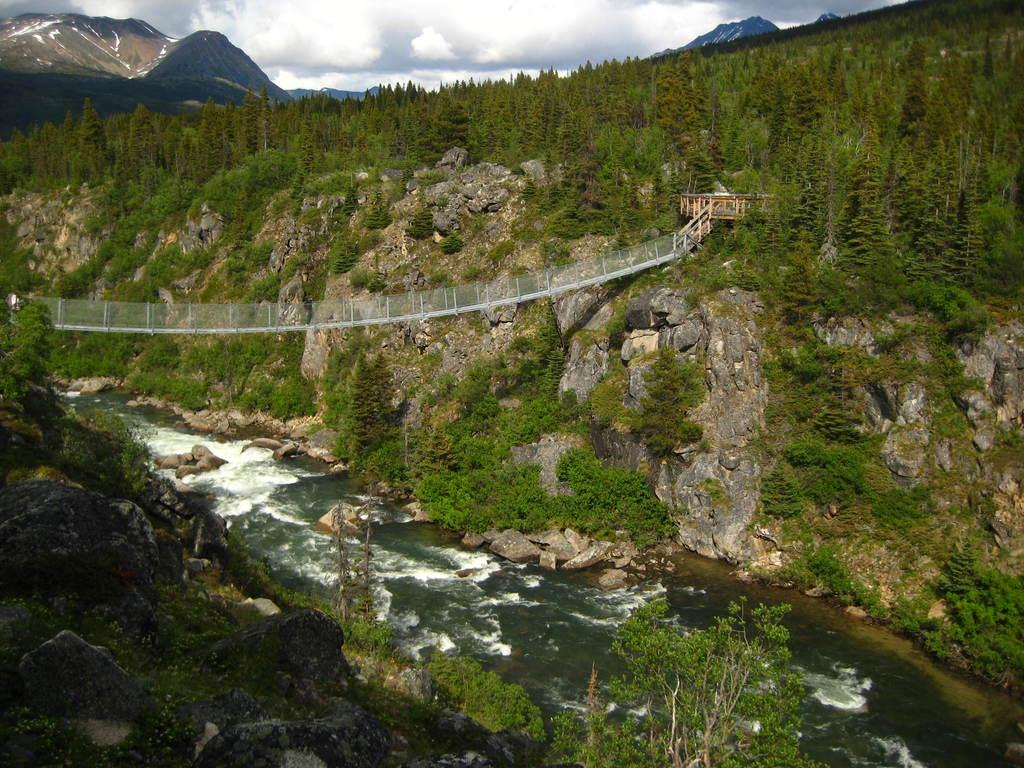What is the main structure in the center of the image? There is a bridge in the center of the image. What is located at the bottom of the image? There is a river at the bottom of the image. What can be seen in the river? There are rocks in the river. What is visible in the background of the image? There are hills, trees, and the sky visible in the background of the image. How many units are present in the image? There is no reference to any units in the image; it features a bridge, a river, rocks, hills, trees, and the sky. 